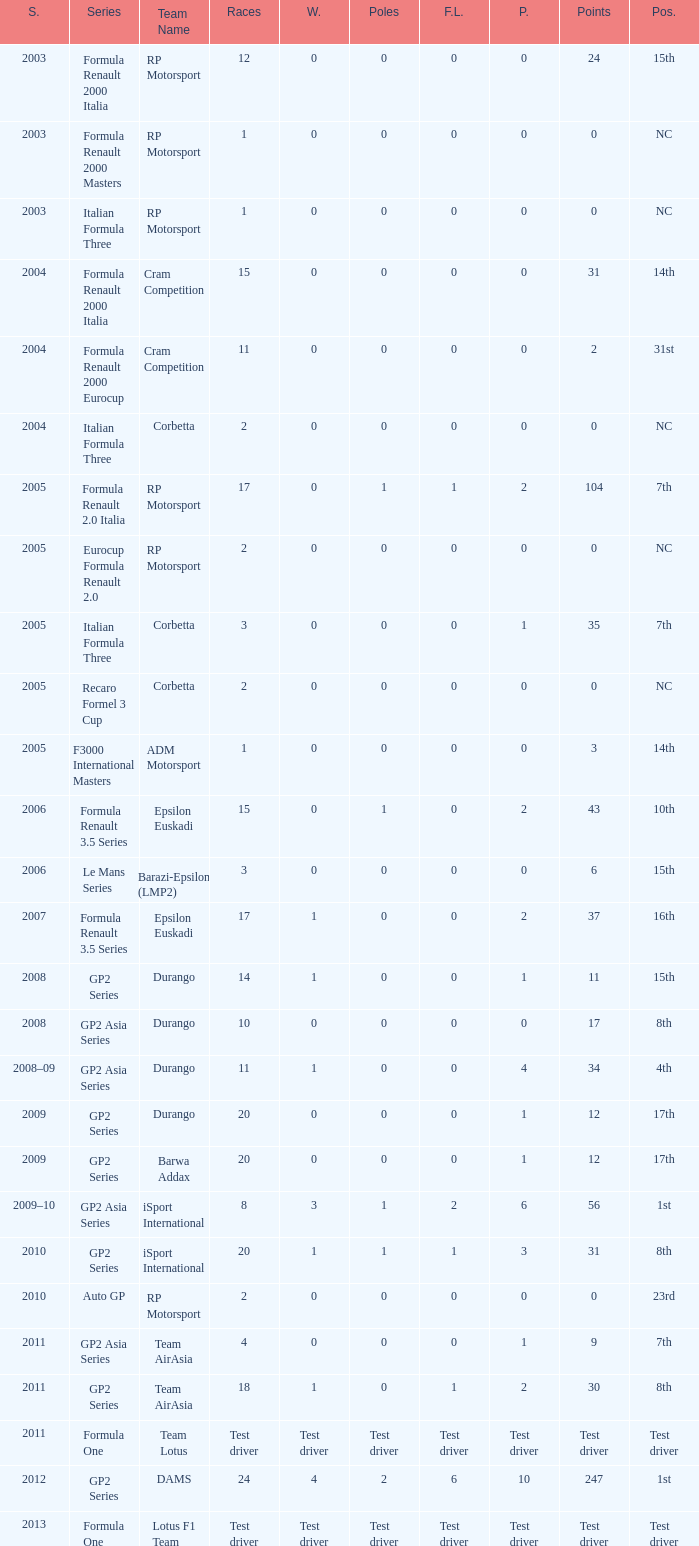What is the number of poles with 4 races? 0.0. 